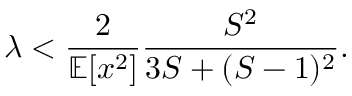Convert formula to latex. <formula><loc_0><loc_0><loc_500><loc_500>\lambda < \frac { 2 } { \mathbb { E } [ x ^ { 2 } ] } \frac { S ^ { 2 } } { 3 S + ( S - 1 ) ^ { 2 } } .</formula> 